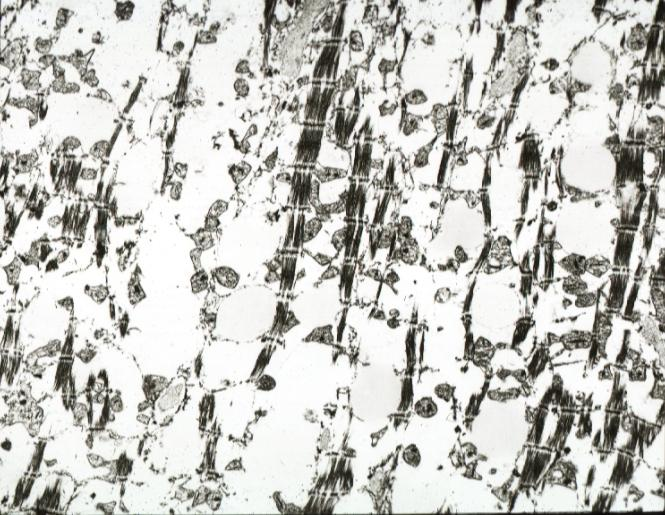s marfans syndrome present?
Answer the question using a single word or phrase. No 